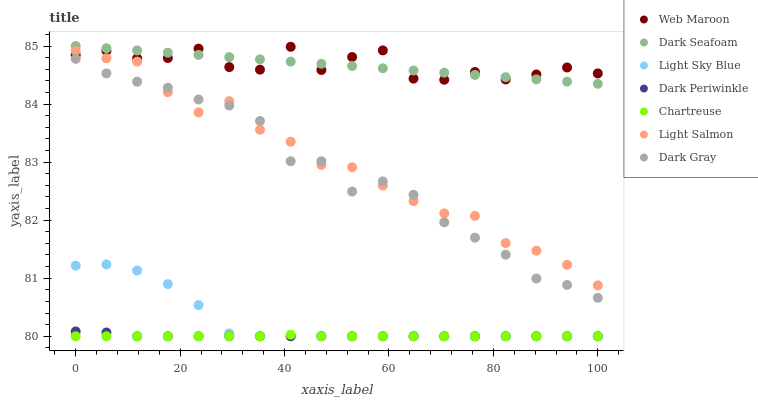Does Chartreuse have the minimum area under the curve?
Answer yes or no. Yes. Does Web Maroon have the maximum area under the curve?
Answer yes or no. Yes. Does Web Maroon have the minimum area under the curve?
Answer yes or no. No. Does Chartreuse have the maximum area under the curve?
Answer yes or no. No. Is Dark Seafoam the smoothest?
Answer yes or no. Yes. Is Web Maroon the roughest?
Answer yes or no. Yes. Is Chartreuse the smoothest?
Answer yes or no. No. Is Chartreuse the roughest?
Answer yes or no. No. Does Chartreuse have the lowest value?
Answer yes or no. Yes. Does Web Maroon have the lowest value?
Answer yes or no. No. Does Dark Seafoam have the highest value?
Answer yes or no. Yes. Does Web Maroon have the highest value?
Answer yes or no. No. Is Light Sky Blue less than Dark Gray?
Answer yes or no. Yes. Is Dark Seafoam greater than Chartreuse?
Answer yes or no. Yes. Does Dark Periwinkle intersect Light Sky Blue?
Answer yes or no. Yes. Is Dark Periwinkle less than Light Sky Blue?
Answer yes or no. No. Is Dark Periwinkle greater than Light Sky Blue?
Answer yes or no. No. Does Light Sky Blue intersect Dark Gray?
Answer yes or no. No. 